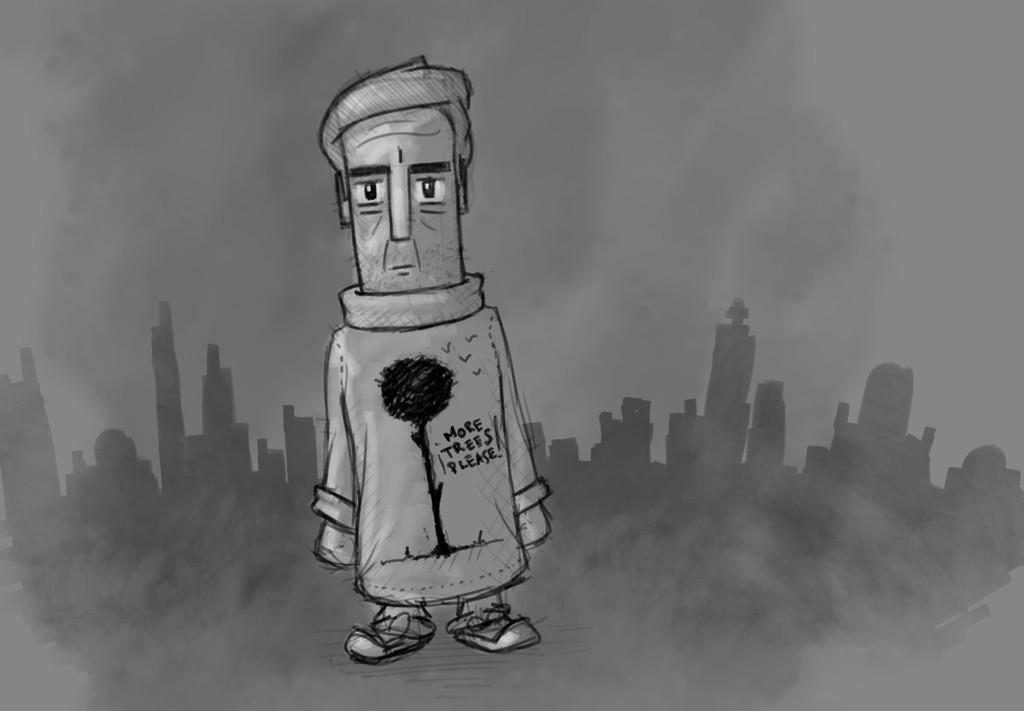Please provide a concise description of this image. In the image we can see an animated picture of a person standing, wearing clothes. There are many buildings, smoke and sky. 